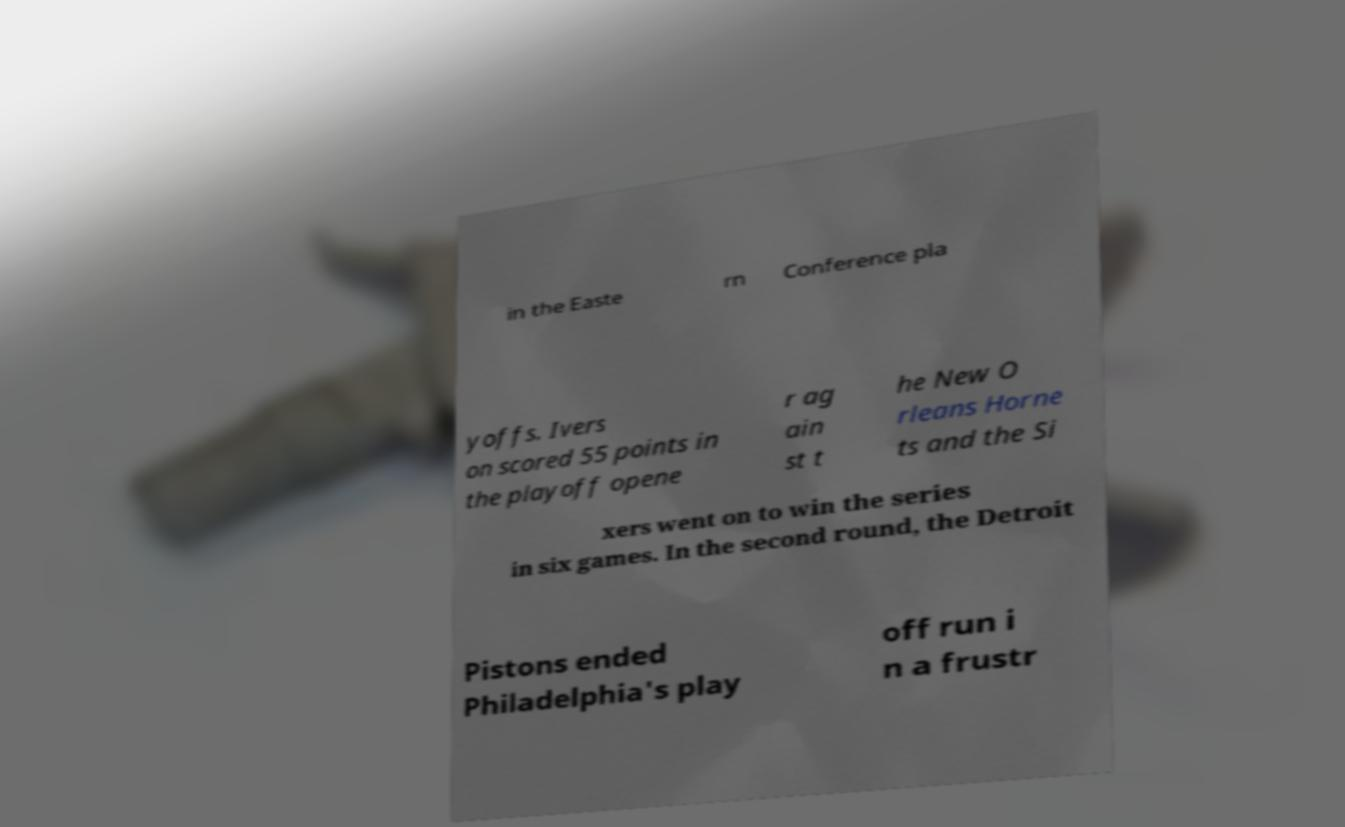There's text embedded in this image that I need extracted. Can you transcribe it verbatim? in the Easte rn Conference pla yoffs. Ivers on scored 55 points in the playoff opene r ag ain st t he New O rleans Horne ts and the Si xers went on to win the series in six games. In the second round, the Detroit Pistons ended Philadelphia's play off run i n a frustr 